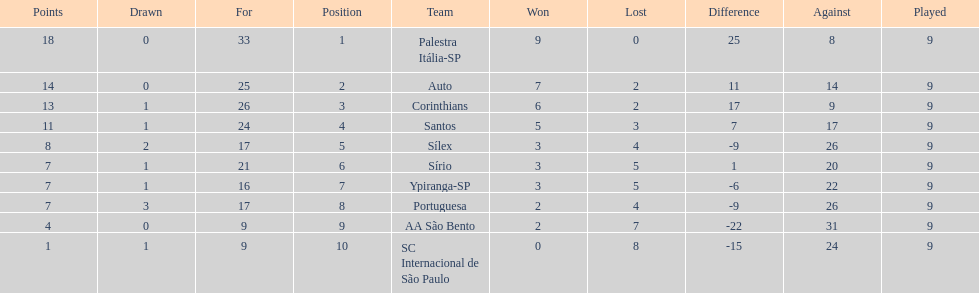In 1926 brazilian football,what was the total number of points scored? 90. 